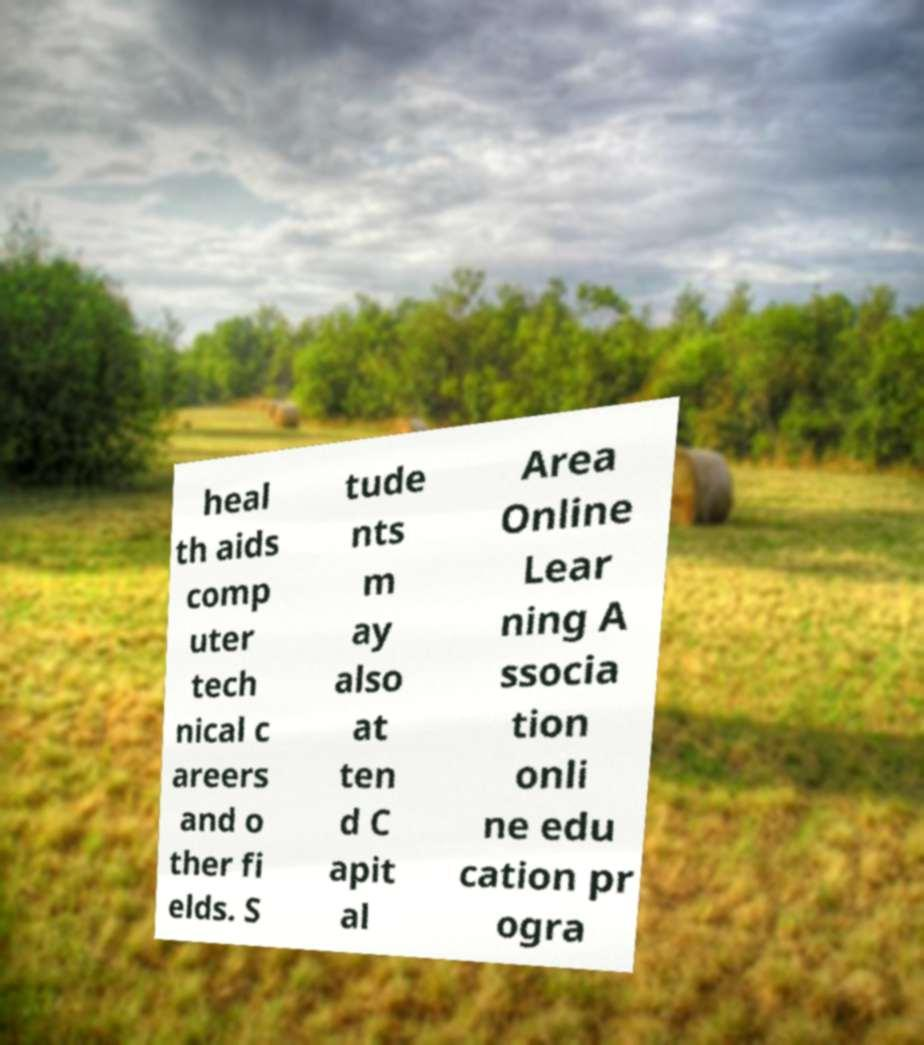I need the written content from this picture converted into text. Can you do that? heal th aids comp uter tech nical c areers and o ther fi elds. S tude nts m ay also at ten d C apit al Area Online Lear ning A ssocia tion onli ne edu cation pr ogra 